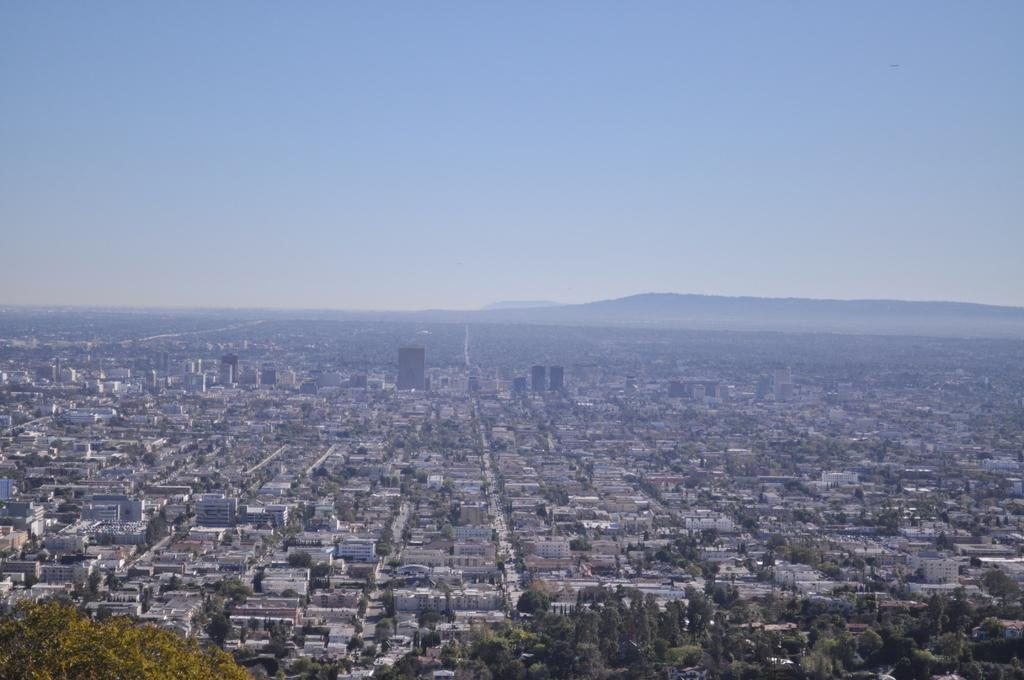What color is the sky in the image? The sky is blue in the image. What structures can be seen in the image? There are buildings in the image. What type of vegetation is present in the image? There are trees in the image. Can you see any dinosaurs in the image? No, there are no dinosaurs present in the image. Is the image set near an ocean? The provided facts do not mention an ocean, so it cannot be determined from the image. 